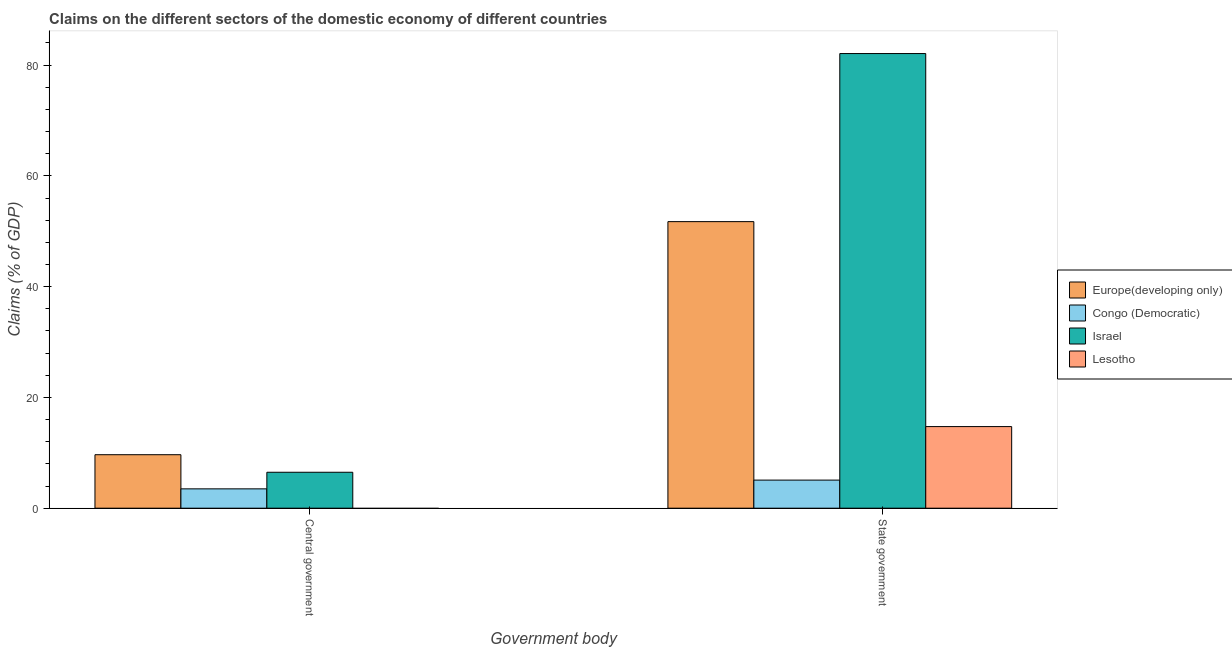How many different coloured bars are there?
Your answer should be compact. 4. How many groups of bars are there?
Offer a very short reply. 2. Are the number of bars per tick equal to the number of legend labels?
Make the answer very short. No. What is the label of the 1st group of bars from the left?
Make the answer very short. Central government. What is the claims on state government in Israel?
Offer a very short reply. 82.08. Across all countries, what is the maximum claims on state government?
Make the answer very short. 82.08. Across all countries, what is the minimum claims on central government?
Give a very brief answer. 0. What is the total claims on central government in the graph?
Provide a short and direct response. 19.64. What is the difference between the claims on state government in Israel and that in Congo (Democratic)?
Provide a short and direct response. 77.01. What is the difference between the claims on state government in Europe(developing only) and the claims on central government in Congo (Democratic)?
Ensure brevity in your answer.  48.25. What is the average claims on state government per country?
Ensure brevity in your answer.  38.41. What is the difference between the claims on central government and claims on state government in Europe(developing only)?
Offer a terse response. -42.08. What is the ratio of the claims on central government in Congo (Democratic) to that in Israel?
Provide a succinct answer. 0.54. Is the claims on state government in Lesotho less than that in Europe(developing only)?
Offer a very short reply. Yes. In how many countries, is the claims on state government greater than the average claims on state government taken over all countries?
Offer a terse response. 2. How many countries are there in the graph?
Your response must be concise. 4. Are the values on the major ticks of Y-axis written in scientific E-notation?
Make the answer very short. No. How are the legend labels stacked?
Make the answer very short. Vertical. What is the title of the graph?
Give a very brief answer. Claims on the different sectors of the domestic economy of different countries. What is the label or title of the X-axis?
Your answer should be compact. Government body. What is the label or title of the Y-axis?
Offer a terse response. Claims (% of GDP). What is the Claims (% of GDP) of Europe(developing only) in Central government?
Offer a terse response. 9.66. What is the Claims (% of GDP) of Congo (Democratic) in Central government?
Your answer should be very brief. 3.49. What is the Claims (% of GDP) in Israel in Central government?
Your answer should be compact. 6.49. What is the Claims (% of GDP) of Europe(developing only) in State government?
Your answer should be compact. 51.74. What is the Claims (% of GDP) in Congo (Democratic) in State government?
Keep it short and to the point. 5.07. What is the Claims (% of GDP) in Israel in State government?
Provide a short and direct response. 82.08. What is the Claims (% of GDP) of Lesotho in State government?
Give a very brief answer. 14.73. Across all Government body, what is the maximum Claims (% of GDP) of Europe(developing only)?
Your response must be concise. 51.74. Across all Government body, what is the maximum Claims (% of GDP) of Congo (Democratic)?
Ensure brevity in your answer.  5.07. Across all Government body, what is the maximum Claims (% of GDP) in Israel?
Your answer should be compact. 82.08. Across all Government body, what is the maximum Claims (% of GDP) of Lesotho?
Give a very brief answer. 14.73. Across all Government body, what is the minimum Claims (% of GDP) in Europe(developing only)?
Offer a terse response. 9.66. Across all Government body, what is the minimum Claims (% of GDP) of Congo (Democratic)?
Ensure brevity in your answer.  3.49. Across all Government body, what is the minimum Claims (% of GDP) in Israel?
Give a very brief answer. 6.49. What is the total Claims (% of GDP) in Europe(developing only) in the graph?
Provide a succinct answer. 61.4. What is the total Claims (% of GDP) in Congo (Democratic) in the graph?
Your response must be concise. 8.56. What is the total Claims (% of GDP) of Israel in the graph?
Provide a short and direct response. 88.57. What is the total Claims (% of GDP) of Lesotho in the graph?
Make the answer very short. 14.73. What is the difference between the Claims (% of GDP) of Europe(developing only) in Central government and that in State government?
Your response must be concise. -42.08. What is the difference between the Claims (% of GDP) of Congo (Democratic) in Central government and that in State government?
Offer a terse response. -1.58. What is the difference between the Claims (% of GDP) of Israel in Central government and that in State government?
Offer a very short reply. -75.6. What is the difference between the Claims (% of GDP) in Europe(developing only) in Central government and the Claims (% of GDP) in Congo (Democratic) in State government?
Offer a terse response. 4.59. What is the difference between the Claims (% of GDP) of Europe(developing only) in Central government and the Claims (% of GDP) of Israel in State government?
Provide a short and direct response. -72.43. What is the difference between the Claims (% of GDP) in Europe(developing only) in Central government and the Claims (% of GDP) in Lesotho in State government?
Give a very brief answer. -5.08. What is the difference between the Claims (% of GDP) of Congo (Democratic) in Central government and the Claims (% of GDP) of Israel in State government?
Make the answer very short. -78.59. What is the difference between the Claims (% of GDP) of Congo (Democratic) in Central government and the Claims (% of GDP) of Lesotho in State government?
Your response must be concise. -11.24. What is the difference between the Claims (% of GDP) of Israel in Central government and the Claims (% of GDP) of Lesotho in State government?
Make the answer very short. -8.25. What is the average Claims (% of GDP) in Europe(developing only) per Government body?
Your answer should be very brief. 30.7. What is the average Claims (% of GDP) in Congo (Democratic) per Government body?
Your answer should be compact. 4.28. What is the average Claims (% of GDP) of Israel per Government body?
Your answer should be very brief. 44.29. What is the average Claims (% of GDP) of Lesotho per Government body?
Ensure brevity in your answer.  7.37. What is the difference between the Claims (% of GDP) of Europe(developing only) and Claims (% of GDP) of Congo (Democratic) in Central government?
Ensure brevity in your answer.  6.16. What is the difference between the Claims (% of GDP) in Europe(developing only) and Claims (% of GDP) in Israel in Central government?
Ensure brevity in your answer.  3.17. What is the difference between the Claims (% of GDP) of Congo (Democratic) and Claims (% of GDP) of Israel in Central government?
Give a very brief answer. -2.99. What is the difference between the Claims (% of GDP) of Europe(developing only) and Claims (% of GDP) of Congo (Democratic) in State government?
Make the answer very short. 46.67. What is the difference between the Claims (% of GDP) in Europe(developing only) and Claims (% of GDP) in Israel in State government?
Give a very brief answer. -30.35. What is the difference between the Claims (% of GDP) in Europe(developing only) and Claims (% of GDP) in Lesotho in State government?
Keep it short and to the point. 37. What is the difference between the Claims (% of GDP) of Congo (Democratic) and Claims (% of GDP) of Israel in State government?
Offer a very short reply. -77.01. What is the difference between the Claims (% of GDP) in Congo (Democratic) and Claims (% of GDP) in Lesotho in State government?
Offer a terse response. -9.66. What is the difference between the Claims (% of GDP) of Israel and Claims (% of GDP) of Lesotho in State government?
Make the answer very short. 67.35. What is the ratio of the Claims (% of GDP) of Europe(developing only) in Central government to that in State government?
Give a very brief answer. 0.19. What is the ratio of the Claims (% of GDP) in Congo (Democratic) in Central government to that in State government?
Offer a terse response. 0.69. What is the ratio of the Claims (% of GDP) in Israel in Central government to that in State government?
Ensure brevity in your answer.  0.08. What is the difference between the highest and the second highest Claims (% of GDP) in Europe(developing only)?
Your answer should be compact. 42.08. What is the difference between the highest and the second highest Claims (% of GDP) of Congo (Democratic)?
Give a very brief answer. 1.58. What is the difference between the highest and the second highest Claims (% of GDP) in Israel?
Ensure brevity in your answer.  75.6. What is the difference between the highest and the lowest Claims (% of GDP) in Europe(developing only)?
Your answer should be compact. 42.08. What is the difference between the highest and the lowest Claims (% of GDP) in Congo (Democratic)?
Your answer should be very brief. 1.58. What is the difference between the highest and the lowest Claims (% of GDP) in Israel?
Your answer should be very brief. 75.6. What is the difference between the highest and the lowest Claims (% of GDP) of Lesotho?
Your answer should be very brief. 14.73. 